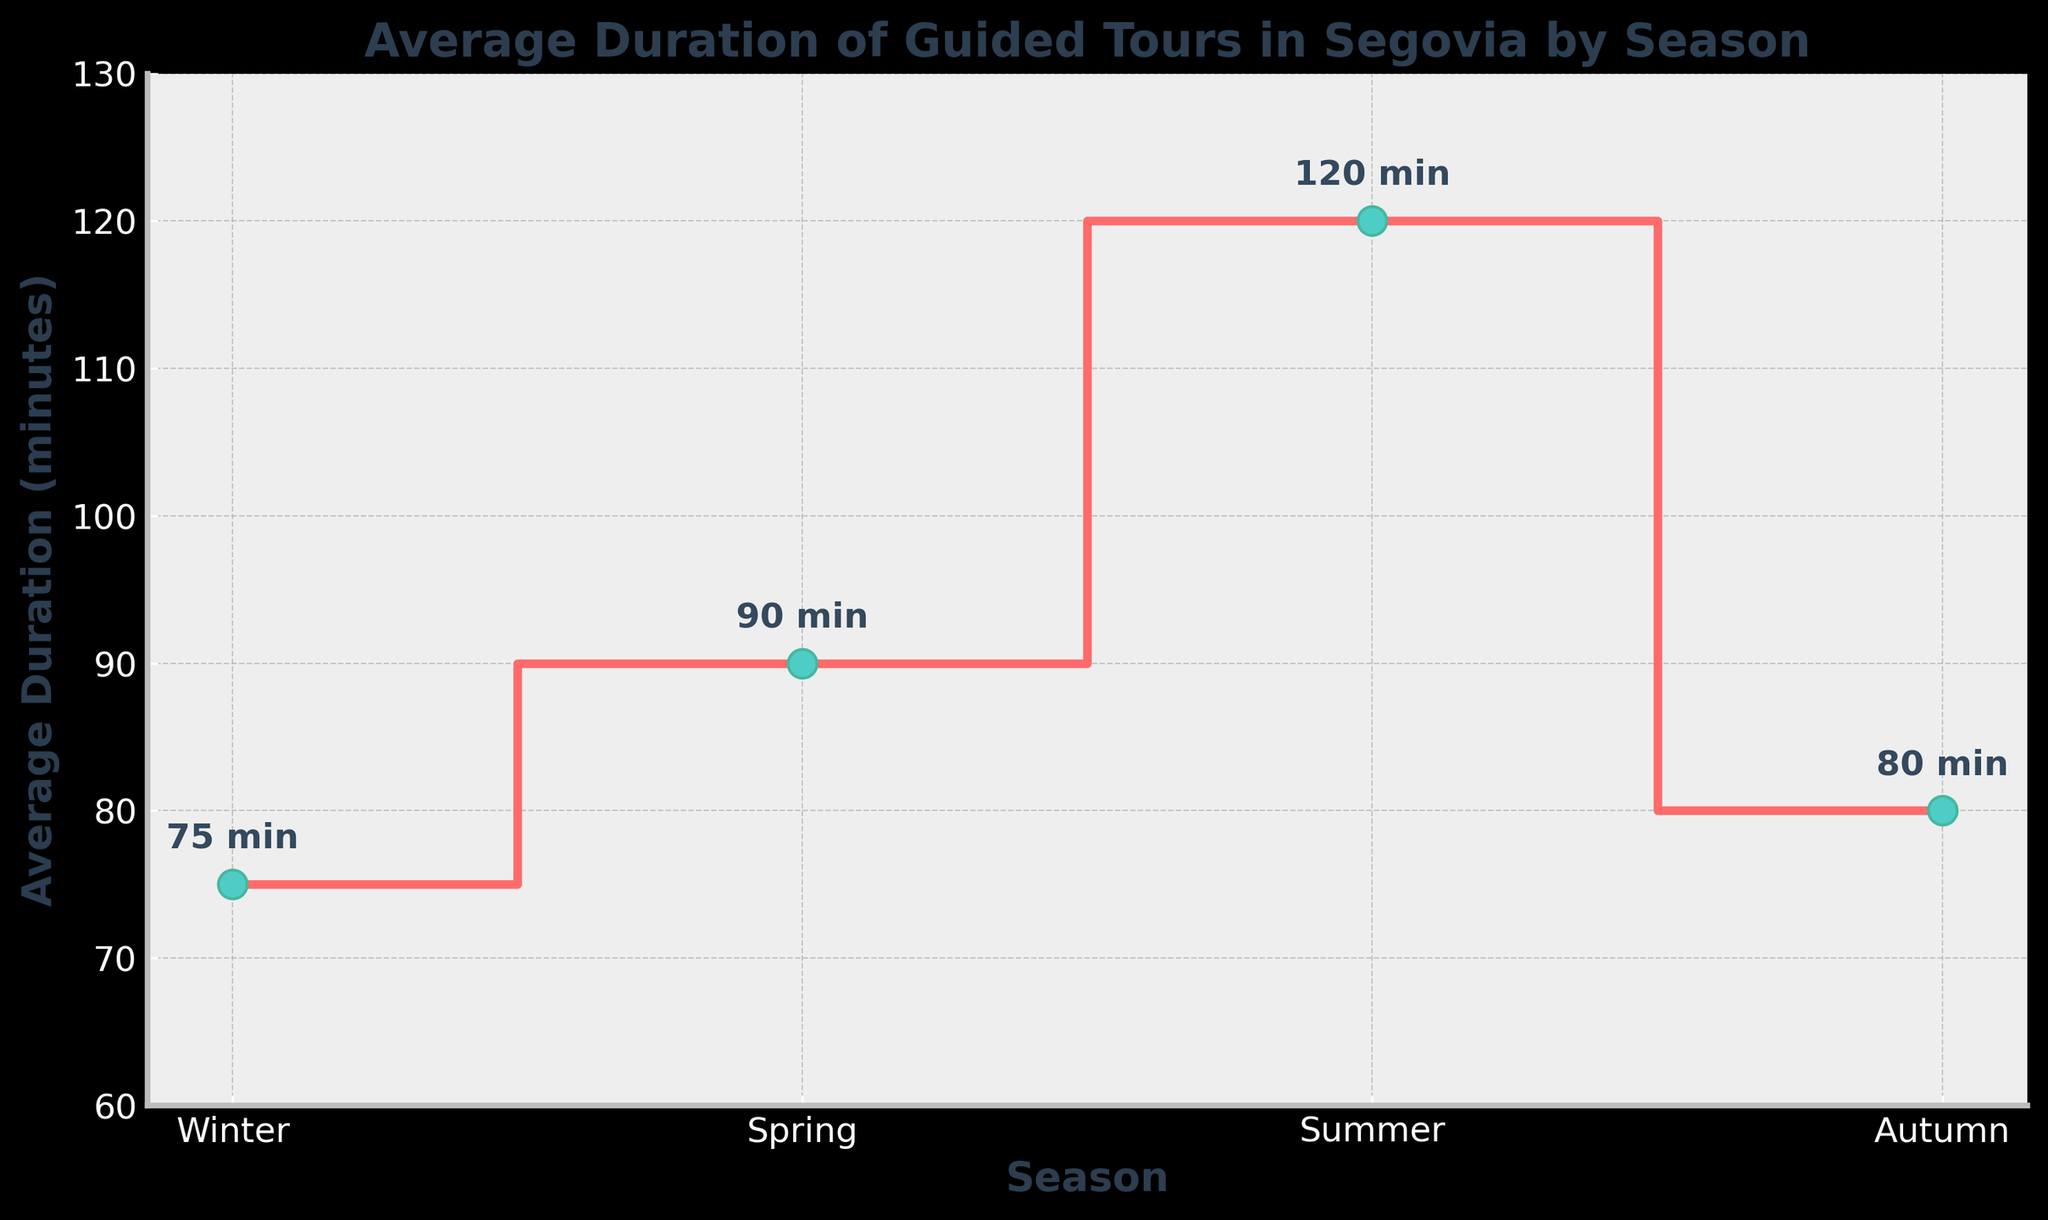What is the title of the figure? The title is usually located at the top of the figure. In this case, it reads 'Average Duration of Guided Tours in Segovia by Season'.
Answer: Average Duration of Guided Tours in Segovia by Season What are the labels of the x-axis and y-axis? The labels of the axes are usually indicated near the axes. The x-axis is labeled 'Season', and the y-axis is labeled 'Average Duration (minutes)'.
Answer: Season; Average Duration (minutes) Which season has the highest average duration? By looking at the steps on the plot and the corresponding y-values, Summer shows the highest point of 120 minutes.
Answer: Summer What is the difference in average duration between Winter and Summer? The average duration in Winter is 75 minutes, and in Summer, it is 120 minutes. The difference is calculated as 120 - 75 = 45 minutes.
Answer: 45 minutes Which season has the lowest average duration? By observing the steps in the plot and their heights, Winter has the lowest point at 75 minutes.
Answer: Winter How many different seasons' data points are plotted in the figure? By counting the number of distinct steps or markers on the x-axis, there are four seasons shown: Winter, Spring, Summer, and Autumn.
Answer: Four What is the average duration across all four seasons? The average duration is calculated by adding the durations together and dividing by the number of seasons: (75 + 90 + 120 + 80) / 4 = 91.25 minutes.
Answer: 91.25 minutes Between which two seasons is there the smallest difference in average duration? Comparing the durations, the smallest difference is between Winter (75 minutes) and Autumn (80 minutes), with a difference of 5 minutes.
Answer: Winter and Autumn What is the increase in average duration from Spring to Summer? The average duration in Spring is 90 minutes and in Summer is 120 minutes. The increase is 120 - 90 = 30 minutes.
Answer: 30 minutes What is the overall range of average durations across the seasons? The range is found by subtracting the smallest value from the largest value. The highest is Summer at 120 minutes, and the lowest is Winter at 75 minutes. The range is 120 - 75 = 45 minutes.
Answer: 45 minutes 